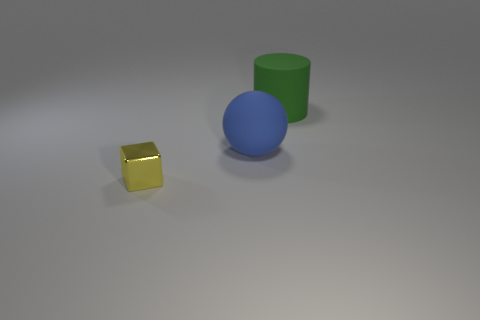Are there any other things that have the same size as the yellow thing?
Offer a terse response. No. Is the number of large blue matte spheres that are behind the big matte cylinder the same as the number of blue matte things that are behind the large blue thing?
Offer a very short reply. Yes. What number of small objects are there?
Ensure brevity in your answer.  1. Are there more large green objects that are to the right of the blue thing than large blue objects?
Offer a terse response. No. What material is the large thing that is behind the big blue sphere?
Keep it short and to the point. Rubber. What number of other matte balls are the same color as the ball?
Your answer should be very brief. 0. There is a metal cube in front of the large green rubber cylinder; does it have the same size as the thing that is to the right of the blue rubber ball?
Offer a very short reply. No. Does the yellow metal object have the same size as the rubber object that is in front of the cylinder?
Offer a terse response. No. What is the size of the cylinder?
Provide a succinct answer. Large. What is the color of the cylinder that is the same material as the blue thing?
Offer a terse response. Green. 